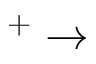Convert formula to latex. <formula><loc_0><loc_0><loc_500><loc_500>^ { + } \rightarrow</formula> 